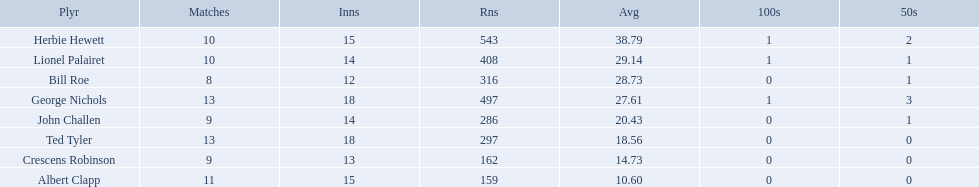Who are all of the players? Herbie Hewett, Lionel Palairet, Bill Roe, George Nichols, John Challen, Ted Tyler, Crescens Robinson, Albert Clapp. How many innings did they play in? 15, 14, 12, 18, 14, 18, 13, 15. Which player was in fewer than 13 innings? Bill Roe. Who are the players in somerset county cricket club in 1890? Herbie Hewett, Lionel Palairet, Bill Roe, George Nichols, John Challen, Ted Tyler, Crescens Robinson, Albert Clapp. Who is the only player to play less than 13 innings? Bill Roe. Which players played in 10 or fewer matches? Herbie Hewett, Lionel Palairet, Bill Roe, John Challen, Crescens Robinson. Of these, which played in only 12 innings? Bill Roe. 